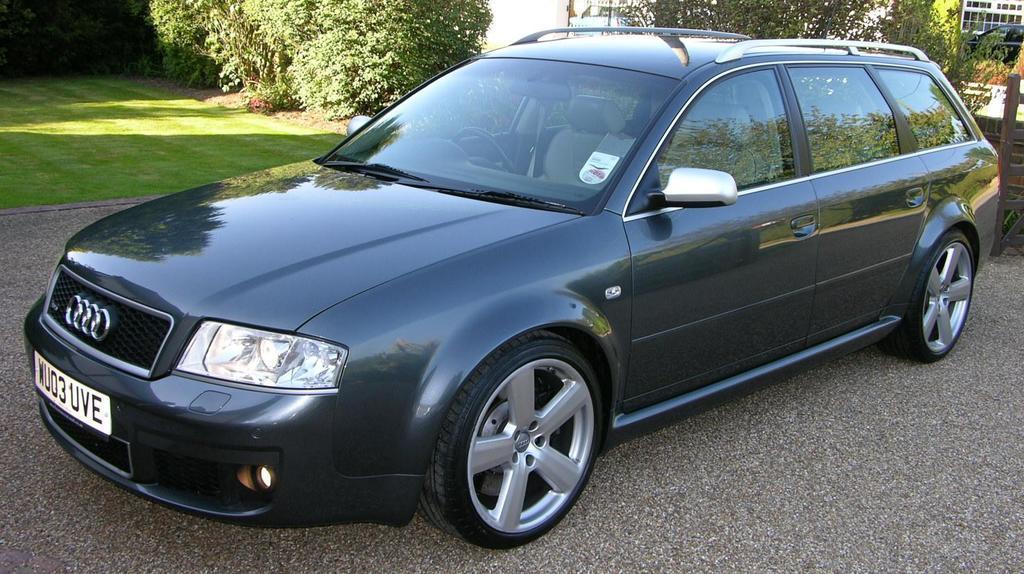Can you describe this image briefly? In front of the picture, we see a car in grey color is parked on the road. At the bottom, we see the road. Behind the car, we see the wooden fence and the trees. On the left side, we see the grass. At the top, we see the trees. There are trees, buildings and vehicles in the background. 